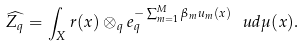Convert formula to latex. <formula><loc_0><loc_0><loc_500><loc_500>\widehat { Z _ { q } } = \int _ { X } r ( x ) \otimes _ { q } e _ { q } ^ { - \sum _ { m = 1 } ^ { M } \beta _ { m } u _ { m } ( x ) } \, \ u d \mu ( x ) .</formula> 